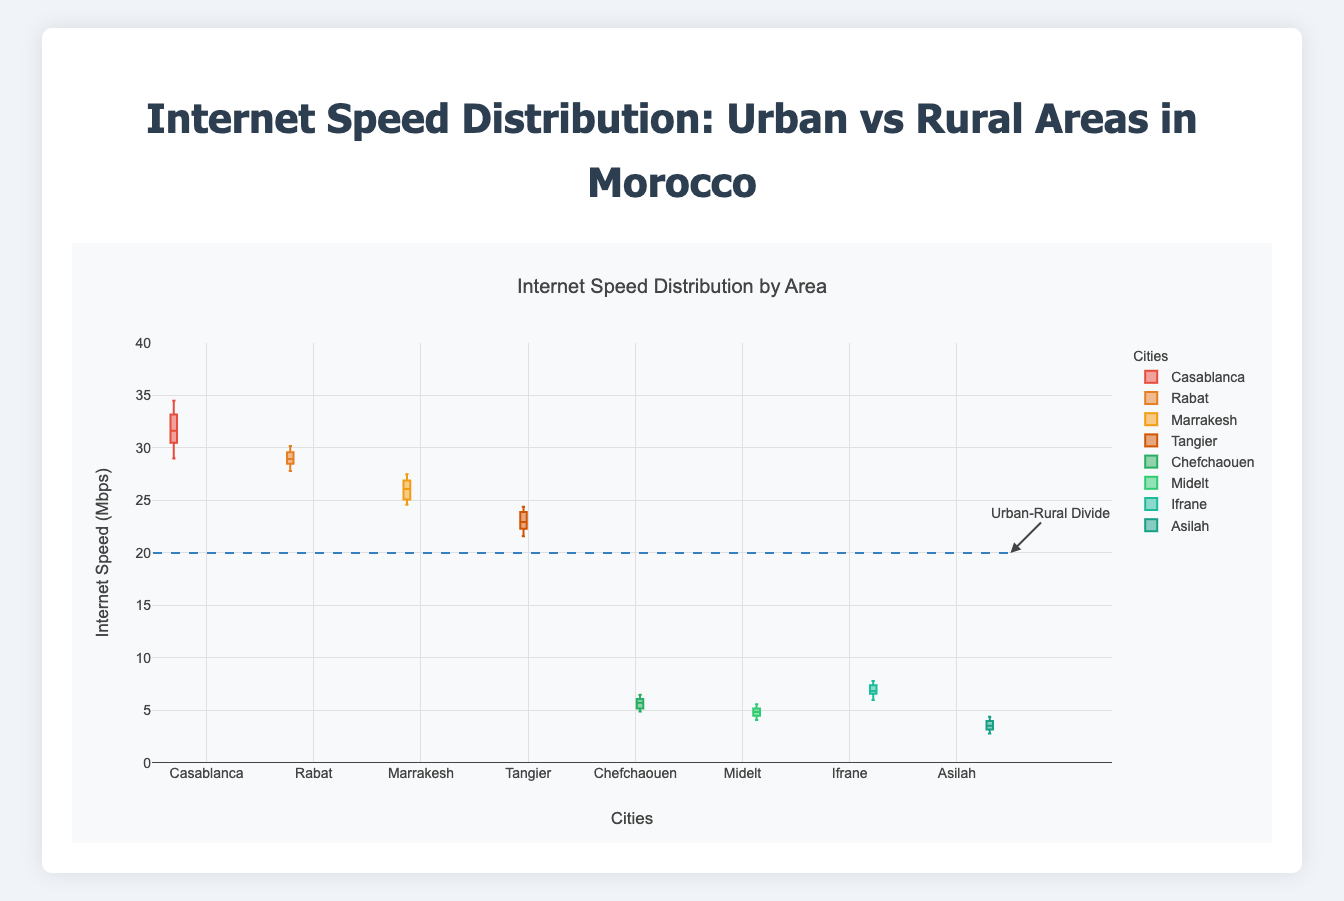What is the title of the figure? The title is typically located at the top of the figure. It describes the overall content or purpose of the figure.
Answer: Internet Speed Distribution: Urban vs Rural Areas in Morocco What is the range of the y-axis? The y-axis range is determined by observing the vertical line markers on the figure's left side, which represent the minimum and maximum values.
Answer: 0 to 40 Mbps Which urban area has the highest median internet speed? The median value of a box plot is represented by the line inside the box. By comparing the medians of all urban areas, we can see which one is the highest.
Answer: Casablanca How do the median internet speeds of urban and rural areas compare? The medians are the central lines in the boxes. Comparing the medians of all urban and rural areas, we observe that urban areas have significantly higher medians than rural areas.
Answer: Urban areas have higher medians What city has the lowest internet speed in the rural areas? By examining the lower whiskers of the box plots for each rural area, the one that extends to the lowest value indicates the city with the lowest internet speed.
Answer: Asilah How does the internet speed spread (interquartile range) of Marrakech compare to that of Chefchaouen? The interquartile range (IQR) is the length of the box in the box plot. By comparing the IQRs of Marrakech and Chefchaouen, we can determine which has a larger spread of internet speeds.
Answer: Marrakech has a larger IQR than Chefchaouen What is the average median internet speed of the urban areas? First, identify the median values for all urban areas: Casablanca, Rabat, Marrakesh, and Tangier. Then, average these medians.
Answer: (31.15 + 29 + 26.2 + 23) / 4 = 27.34 Mbps Which city has the smallest range of internet speeds in the urban areas? The range is the difference between the highest and lowest points (whiskers) of the box plots. Observing the box plots for urban areas, determine which one has the shortest whiskers' span.
Answer: Rabat Which rural area has the highest variability in internet speed? The variability is indicated by the length of the box and whiskers. The rural area with the longest box or whiskers exhibits the highest variability.
Answer: Ifrane 